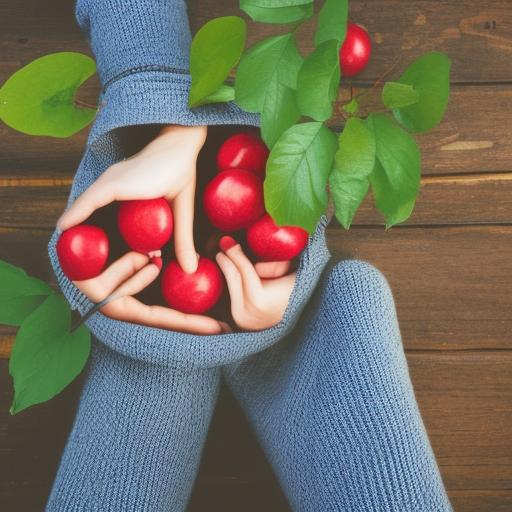Could you describe the aesthetic or mood that this image conveys? The image exudes a cozy, autumnal vibe with its earthy tones and the vibrant red apples contrasting with the subdued blue of the knitted sweater. It's reminiscent of harvest time and comfortably cool weather, potentially evoking feelings of comfort, gratitude, and seasonal change. 